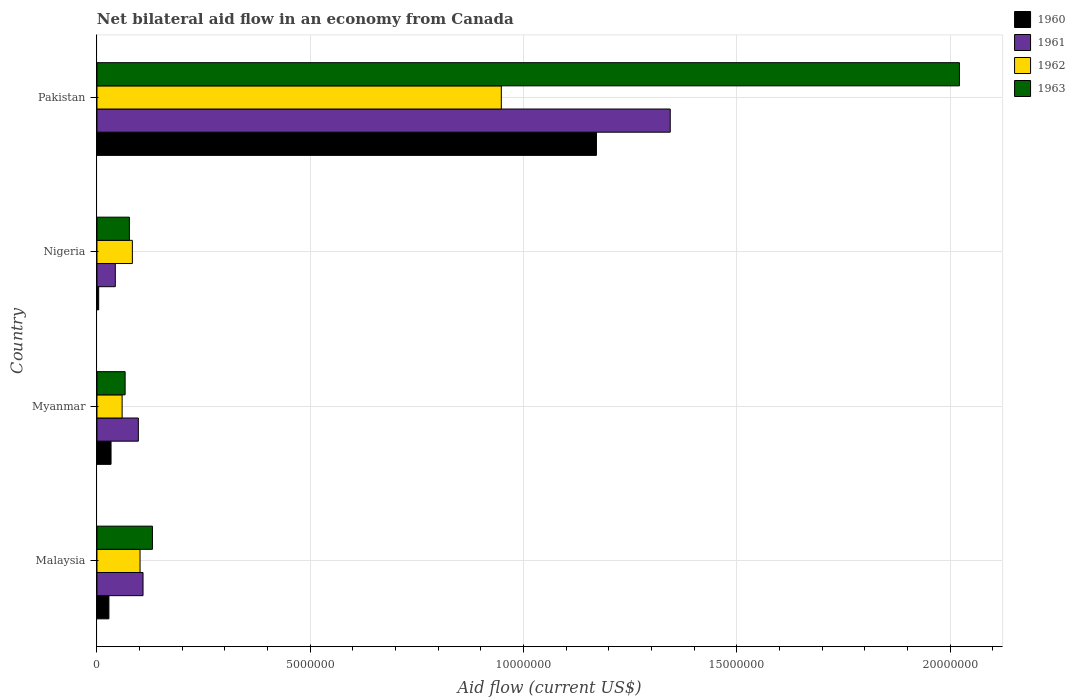How many bars are there on the 4th tick from the bottom?
Offer a very short reply. 4. What is the label of the 2nd group of bars from the top?
Provide a succinct answer. Nigeria. Across all countries, what is the maximum net bilateral aid flow in 1960?
Provide a short and direct response. 1.17e+07. In which country was the net bilateral aid flow in 1960 minimum?
Make the answer very short. Nigeria. What is the total net bilateral aid flow in 1963 in the graph?
Give a very brief answer. 2.29e+07. What is the difference between the net bilateral aid flow in 1961 in Myanmar and that in Nigeria?
Offer a very short reply. 5.40e+05. What is the difference between the net bilateral aid flow in 1961 in Myanmar and the net bilateral aid flow in 1963 in Pakistan?
Your answer should be very brief. -1.92e+07. What is the average net bilateral aid flow in 1960 per country?
Offer a very short reply. 3.09e+06. What is the difference between the net bilateral aid flow in 1963 and net bilateral aid flow in 1961 in Pakistan?
Keep it short and to the point. 6.78e+06. In how many countries, is the net bilateral aid flow in 1962 greater than 8000000 US$?
Provide a short and direct response. 1. What is the ratio of the net bilateral aid flow in 1961 in Nigeria to that in Pakistan?
Provide a succinct answer. 0.03. Is the difference between the net bilateral aid flow in 1963 in Malaysia and Nigeria greater than the difference between the net bilateral aid flow in 1961 in Malaysia and Nigeria?
Your response must be concise. No. What is the difference between the highest and the second highest net bilateral aid flow in 1961?
Give a very brief answer. 1.24e+07. What is the difference between the highest and the lowest net bilateral aid flow in 1962?
Offer a terse response. 8.89e+06. Is the sum of the net bilateral aid flow in 1963 in Nigeria and Pakistan greater than the maximum net bilateral aid flow in 1961 across all countries?
Offer a terse response. Yes. Is it the case that in every country, the sum of the net bilateral aid flow in 1963 and net bilateral aid flow in 1962 is greater than the sum of net bilateral aid flow in 1960 and net bilateral aid flow in 1961?
Provide a short and direct response. No. What does the 1st bar from the bottom in Myanmar represents?
Your response must be concise. 1960. How many bars are there?
Offer a very short reply. 16. How many countries are there in the graph?
Offer a very short reply. 4. Are the values on the major ticks of X-axis written in scientific E-notation?
Keep it short and to the point. No. Does the graph contain any zero values?
Make the answer very short. No. Does the graph contain grids?
Your answer should be very brief. Yes. Where does the legend appear in the graph?
Ensure brevity in your answer.  Top right. What is the title of the graph?
Provide a short and direct response. Net bilateral aid flow in an economy from Canada. What is the label or title of the X-axis?
Keep it short and to the point. Aid flow (current US$). What is the Aid flow (current US$) in 1960 in Malaysia?
Your answer should be very brief. 2.80e+05. What is the Aid flow (current US$) in 1961 in Malaysia?
Your answer should be compact. 1.08e+06. What is the Aid flow (current US$) in 1962 in Malaysia?
Keep it short and to the point. 1.01e+06. What is the Aid flow (current US$) in 1963 in Malaysia?
Offer a terse response. 1.30e+06. What is the Aid flow (current US$) in 1960 in Myanmar?
Your response must be concise. 3.30e+05. What is the Aid flow (current US$) in 1961 in Myanmar?
Ensure brevity in your answer.  9.70e+05. What is the Aid flow (current US$) of 1962 in Myanmar?
Provide a succinct answer. 5.90e+05. What is the Aid flow (current US$) of 1962 in Nigeria?
Your answer should be very brief. 8.30e+05. What is the Aid flow (current US$) in 1963 in Nigeria?
Offer a very short reply. 7.60e+05. What is the Aid flow (current US$) in 1960 in Pakistan?
Offer a terse response. 1.17e+07. What is the Aid flow (current US$) in 1961 in Pakistan?
Keep it short and to the point. 1.34e+07. What is the Aid flow (current US$) in 1962 in Pakistan?
Ensure brevity in your answer.  9.48e+06. What is the Aid flow (current US$) of 1963 in Pakistan?
Your response must be concise. 2.02e+07. Across all countries, what is the maximum Aid flow (current US$) of 1960?
Keep it short and to the point. 1.17e+07. Across all countries, what is the maximum Aid flow (current US$) in 1961?
Ensure brevity in your answer.  1.34e+07. Across all countries, what is the maximum Aid flow (current US$) of 1962?
Your answer should be compact. 9.48e+06. Across all countries, what is the maximum Aid flow (current US$) in 1963?
Give a very brief answer. 2.02e+07. Across all countries, what is the minimum Aid flow (current US$) in 1961?
Provide a short and direct response. 4.30e+05. Across all countries, what is the minimum Aid flow (current US$) of 1962?
Your response must be concise. 5.90e+05. Across all countries, what is the minimum Aid flow (current US$) in 1963?
Offer a very short reply. 6.60e+05. What is the total Aid flow (current US$) in 1960 in the graph?
Your answer should be very brief. 1.24e+07. What is the total Aid flow (current US$) in 1961 in the graph?
Make the answer very short. 1.59e+07. What is the total Aid flow (current US$) in 1962 in the graph?
Your answer should be very brief. 1.19e+07. What is the total Aid flow (current US$) of 1963 in the graph?
Your answer should be compact. 2.29e+07. What is the difference between the Aid flow (current US$) in 1960 in Malaysia and that in Myanmar?
Ensure brevity in your answer.  -5.00e+04. What is the difference between the Aid flow (current US$) of 1961 in Malaysia and that in Myanmar?
Your response must be concise. 1.10e+05. What is the difference between the Aid flow (current US$) in 1962 in Malaysia and that in Myanmar?
Provide a short and direct response. 4.20e+05. What is the difference between the Aid flow (current US$) of 1963 in Malaysia and that in Myanmar?
Provide a short and direct response. 6.40e+05. What is the difference between the Aid flow (current US$) of 1961 in Malaysia and that in Nigeria?
Provide a short and direct response. 6.50e+05. What is the difference between the Aid flow (current US$) in 1963 in Malaysia and that in Nigeria?
Your answer should be compact. 5.40e+05. What is the difference between the Aid flow (current US$) of 1960 in Malaysia and that in Pakistan?
Make the answer very short. -1.14e+07. What is the difference between the Aid flow (current US$) in 1961 in Malaysia and that in Pakistan?
Keep it short and to the point. -1.24e+07. What is the difference between the Aid flow (current US$) of 1962 in Malaysia and that in Pakistan?
Ensure brevity in your answer.  -8.47e+06. What is the difference between the Aid flow (current US$) of 1963 in Malaysia and that in Pakistan?
Keep it short and to the point. -1.89e+07. What is the difference between the Aid flow (current US$) of 1960 in Myanmar and that in Nigeria?
Give a very brief answer. 2.90e+05. What is the difference between the Aid flow (current US$) in 1961 in Myanmar and that in Nigeria?
Offer a terse response. 5.40e+05. What is the difference between the Aid flow (current US$) of 1960 in Myanmar and that in Pakistan?
Make the answer very short. -1.14e+07. What is the difference between the Aid flow (current US$) of 1961 in Myanmar and that in Pakistan?
Provide a short and direct response. -1.25e+07. What is the difference between the Aid flow (current US$) of 1962 in Myanmar and that in Pakistan?
Keep it short and to the point. -8.89e+06. What is the difference between the Aid flow (current US$) in 1963 in Myanmar and that in Pakistan?
Your answer should be compact. -1.96e+07. What is the difference between the Aid flow (current US$) of 1960 in Nigeria and that in Pakistan?
Give a very brief answer. -1.17e+07. What is the difference between the Aid flow (current US$) of 1961 in Nigeria and that in Pakistan?
Your response must be concise. -1.30e+07. What is the difference between the Aid flow (current US$) in 1962 in Nigeria and that in Pakistan?
Your response must be concise. -8.65e+06. What is the difference between the Aid flow (current US$) in 1963 in Nigeria and that in Pakistan?
Your response must be concise. -1.95e+07. What is the difference between the Aid flow (current US$) of 1960 in Malaysia and the Aid flow (current US$) of 1961 in Myanmar?
Make the answer very short. -6.90e+05. What is the difference between the Aid flow (current US$) in 1960 in Malaysia and the Aid flow (current US$) in 1962 in Myanmar?
Offer a very short reply. -3.10e+05. What is the difference between the Aid flow (current US$) in 1960 in Malaysia and the Aid flow (current US$) in 1963 in Myanmar?
Your answer should be very brief. -3.80e+05. What is the difference between the Aid flow (current US$) of 1960 in Malaysia and the Aid flow (current US$) of 1962 in Nigeria?
Your response must be concise. -5.50e+05. What is the difference between the Aid flow (current US$) of 1960 in Malaysia and the Aid flow (current US$) of 1963 in Nigeria?
Keep it short and to the point. -4.80e+05. What is the difference between the Aid flow (current US$) in 1961 in Malaysia and the Aid flow (current US$) in 1963 in Nigeria?
Offer a very short reply. 3.20e+05. What is the difference between the Aid flow (current US$) in 1962 in Malaysia and the Aid flow (current US$) in 1963 in Nigeria?
Keep it short and to the point. 2.50e+05. What is the difference between the Aid flow (current US$) of 1960 in Malaysia and the Aid flow (current US$) of 1961 in Pakistan?
Your answer should be very brief. -1.32e+07. What is the difference between the Aid flow (current US$) in 1960 in Malaysia and the Aid flow (current US$) in 1962 in Pakistan?
Make the answer very short. -9.20e+06. What is the difference between the Aid flow (current US$) in 1960 in Malaysia and the Aid flow (current US$) in 1963 in Pakistan?
Your answer should be very brief. -1.99e+07. What is the difference between the Aid flow (current US$) in 1961 in Malaysia and the Aid flow (current US$) in 1962 in Pakistan?
Ensure brevity in your answer.  -8.40e+06. What is the difference between the Aid flow (current US$) in 1961 in Malaysia and the Aid flow (current US$) in 1963 in Pakistan?
Your response must be concise. -1.91e+07. What is the difference between the Aid flow (current US$) in 1962 in Malaysia and the Aid flow (current US$) in 1963 in Pakistan?
Keep it short and to the point. -1.92e+07. What is the difference between the Aid flow (current US$) in 1960 in Myanmar and the Aid flow (current US$) in 1961 in Nigeria?
Make the answer very short. -1.00e+05. What is the difference between the Aid flow (current US$) in 1960 in Myanmar and the Aid flow (current US$) in 1962 in Nigeria?
Offer a terse response. -5.00e+05. What is the difference between the Aid flow (current US$) in 1960 in Myanmar and the Aid flow (current US$) in 1963 in Nigeria?
Your answer should be very brief. -4.30e+05. What is the difference between the Aid flow (current US$) of 1961 in Myanmar and the Aid flow (current US$) of 1962 in Nigeria?
Ensure brevity in your answer.  1.40e+05. What is the difference between the Aid flow (current US$) in 1960 in Myanmar and the Aid flow (current US$) in 1961 in Pakistan?
Your response must be concise. -1.31e+07. What is the difference between the Aid flow (current US$) of 1960 in Myanmar and the Aid flow (current US$) of 1962 in Pakistan?
Your response must be concise. -9.15e+06. What is the difference between the Aid flow (current US$) in 1960 in Myanmar and the Aid flow (current US$) in 1963 in Pakistan?
Your answer should be compact. -1.99e+07. What is the difference between the Aid flow (current US$) of 1961 in Myanmar and the Aid flow (current US$) of 1962 in Pakistan?
Your answer should be very brief. -8.51e+06. What is the difference between the Aid flow (current US$) of 1961 in Myanmar and the Aid flow (current US$) of 1963 in Pakistan?
Ensure brevity in your answer.  -1.92e+07. What is the difference between the Aid flow (current US$) in 1962 in Myanmar and the Aid flow (current US$) in 1963 in Pakistan?
Your answer should be compact. -1.96e+07. What is the difference between the Aid flow (current US$) in 1960 in Nigeria and the Aid flow (current US$) in 1961 in Pakistan?
Give a very brief answer. -1.34e+07. What is the difference between the Aid flow (current US$) of 1960 in Nigeria and the Aid flow (current US$) of 1962 in Pakistan?
Provide a succinct answer. -9.44e+06. What is the difference between the Aid flow (current US$) in 1960 in Nigeria and the Aid flow (current US$) in 1963 in Pakistan?
Give a very brief answer. -2.02e+07. What is the difference between the Aid flow (current US$) in 1961 in Nigeria and the Aid flow (current US$) in 1962 in Pakistan?
Make the answer very short. -9.05e+06. What is the difference between the Aid flow (current US$) in 1961 in Nigeria and the Aid flow (current US$) in 1963 in Pakistan?
Keep it short and to the point. -1.98e+07. What is the difference between the Aid flow (current US$) of 1962 in Nigeria and the Aid flow (current US$) of 1963 in Pakistan?
Give a very brief answer. -1.94e+07. What is the average Aid flow (current US$) in 1960 per country?
Make the answer very short. 3.09e+06. What is the average Aid flow (current US$) in 1961 per country?
Offer a very short reply. 3.98e+06. What is the average Aid flow (current US$) in 1962 per country?
Give a very brief answer. 2.98e+06. What is the average Aid flow (current US$) in 1963 per country?
Make the answer very short. 5.74e+06. What is the difference between the Aid flow (current US$) in 1960 and Aid flow (current US$) in 1961 in Malaysia?
Provide a short and direct response. -8.00e+05. What is the difference between the Aid flow (current US$) of 1960 and Aid flow (current US$) of 1962 in Malaysia?
Provide a short and direct response. -7.30e+05. What is the difference between the Aid flow (current US$) of 1960 and Aid flow (current US$) of 1963 in Malaysia?
Provide a succinct answer. -1.02e+06. What is the difference between the Aid flow (current US$) of 1961 and Aid flow (current US$) of 1963 in Malaysia?
Ensure brevity in your answer.  -2.20e+05. What is the difference between the Aid flow (current US$) of 1960 and Aid flow (current US$) of 1961 in Myanmar?
Offer a terse response. -6.40e+05. What is the difference between the Aid flow (current US$) in 1960 and Aid flow (current US$) in 1963 in Myanmar?
Make the answer very short. -3.30e+05. What is the difference between the Aid flow (current US$) in 1961 and Aid flow (current US$) in 1962 in Myanmar?
Offer a terse response. 3.80e+05. What is the difference between the Aid flow (current US$) of 1960 and Aid flow (current US$) of 1961 in Nigeria?
Offer a very short reply. -3.90e+05. What is the difference between the Aid flow (current US$) in 1960 and Aid flow (current US$) in 1962 in Nigeria?
Keep it short and to the point. -7.90e+05. What is the difference between the Aid flow (current US$) in 1960 and Aid flow (current US$) in 1963 in Nigeria?
Provide a succinct answer. -7.20e+05. What is the difference between the Aid flow (current US$) of 1961 and Aid flow (current US$) of 1962 in Nigeria?
Offer a very short reply. -4.00e+05. What is the difference between the Aid flow (current US$) in 1961 and Aid flow (current US$) in 1963 in Nigeria?
Ensure brevity in your answer.  -3.30e+05. What is the difference between the Aid flow (current US$) of 1962 and Aid flow (current US$) of 1963 in Nigeria?
Keep it short and to the point. 7.00e+04. What is the difference between the Aid flow (current US$) of 1960 and Aid flow (current US$) of 1961 in Pakistan?
Offer a very short reply. -1.73e+06. What is the difference between the Aid flow (current US$) in 1960 and Aid flow (current US$) in 1962 in Pakistan?
Make the answer very short. 2.23e+06. What is the difference between the Aid flow (current US$) of 1960 and Aid flow (current US$) of 1963 in Pakistan?
Give a very brief answer. -8.51e+06. What is the difference between the Aid flow (current US$) of 1961 and Aid flow (current US$) of 1962 in Pakistan?
Provide a succinct answer. 3.96e+06. What is the difference between the Aid flow (current US$) of 1961 and Aid flow (current US$) of 1963 in Pakistan?
Provide a short and direct response. -6.78e+06. What is the difference between the Aid flow (current US$) in 1962 and Aid flow (current US$) in 1963 in Pakistan?
Your answer should be very brief. -1.07e+07. What is the ratio of the Aid flow (current US$) of 1960 in Malaysia to that in Myanmar?
Give a very brief answer. 0.85. What is the ratio of the Aid flow (current US$) of 1961 in Malaysia to that in Myanmar?
Offer a very short reply. 1.11. What is the ratio of the Aid flow (current US$) in 1962 in Malaysia to that in Myanmar?
Give a very brief answer. 1.71. What is the ratio of the Aid flow (current US$) of 1963 in Malaysia to that in Myanmar?
Your answer should be very brief. 1.97. What is the ratio of the Aid flow (current US$) in 1961 in Malaysia to that in Nigeria?
Offer a very short reply. 2.51. What is the ratio of the Aid flow (current US$) of 1962 in Malaysia to that in Nigeria?
Your answer should be compact. 1.22. What is the ratio of the Aid flow (current US$) of 1963 in Malaysia to that in Nigeria?
Offer a terse response. 1.71. What is the ratio of the Aid flow (current US$) in 1960 in Malaysia to that in Pakistan?
Your response must be concise. 0.02. What is the ratio of the Aid flow (current US$) of 1961 in Malaysia to that in Pakistan?
Provide a succinct answer. 0.08. What is the ratio of the Aid flow (current US$) of 1962 in Malaysia to that in Pakistan?
Make the answer very short. 0.11. What is the ratio of the Aid flow (current US$) in 1963 in Malaysia to that in Pakistan?
Offer a terse response. 0.06. What is the ratio of the Aid flow (current US$) in 1960 in Myanmar to that in Nigeria?
Provide a succinct answer. 8.25. What is the ratio of the Aid flow (current US$) of 1961 in Myanmar to that in Nigeria?
Offer a terse response. 2.26. What is the ratio of the Aid flow (current US$) in 1962 in Myanmar to that in Nigeria?
Keep it short and to the point. 0.71. What is the ratio of the Aid flow (current US$) of 1963 in Myanmar to that in Nigeria?
Provide a short and direct response. 0.87. What is the ratio of the Aid flow (current US$) in 1960 in Myanmar to that in Pakistan?
Ensure brevity in your answer.  0.03. What is the ratio of the Aid flow (current US$) in 1961 in Myanmar to that in Pakistan?
Offer a terse response. 0.07. What is the ratio of the Aid flow (current US$) of 1962 in Myanmar to that in Pakistan?
Your answer should be compact. 0.06. What is the ratio of the Aid flow (current US$) in 1963 in Myanmar to that in Pakistan?
Give a very brief answer. 0.03. What is the ratio of the Aid flow (current US$) in 1960 in Nigeria to that in Pakistan?
Your response must be concise. 0. What is the ratio of the Aid flow (current US$) of 1961 in Nigeria to that in Pakistan?
Offer a very short reply. 0.03. What is the ratio of the Aid flow (current US$) in 1962 in Nigeria to that in Pakistan?
Give a very brief answer. 0.09. What is the ratio of the Aid flow (current US$) in 1963 in Nigeria to that in Pakistan?
Offer a very short reply. 0.04. What is the difference between the highest and the second highest Aid flow (current US$) of 1960?
Your answer should be compact. 1.14e+07. What is the difference between the highest and the second highest Aid flow (current US$) in 1961?
Your response must be concise. 1.24e+07. What is the difference between the highest and the second highest Aid flow (current US$) in 1962?
Provide a short and direct response. 8.47e+06. What is the difference between the highest and the second highest Aid flow (current US$) in 1963?
Give a very brief answer. 1.89e+07. What is the difference between the highest and the lowest Aid flow (current US$) of 1960?
Your answer should be compact. 1.17e+07. What is the difference between the highest and the lowest Aid flow (current US$) of 1961?
Make the answer very short. 1.30e+07. What is the difference between the highest and the lowest Aid flow (current US$) of 1962?
Ensure brevity in your answer.  8.89e+06. What is the difference between the highest and the lowest Aid flow (current US$) in 1963?
Provide a succinct answer. 1.96e+07. 